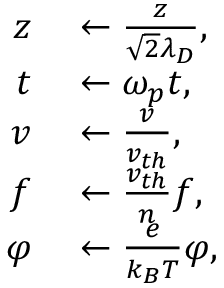Convert formula to latex. <formula><loc_0><loc_0><loc_500><loc_500>\begin{array} { r l } { z } & \leftarrow \frac { z } { \sqrt { 2 } \lambda _ { D } } , } \\ { t } & \leftarrow \omega _ { p } t , } \\ { v } & \leftarrow \frac { v } { v _ { t h } } , } \\ { f } & \leftarrow \frac { v _ { t h } } { n } f , } \\ { \varphi } & \leftarrow \frac { e } { k _ { B } T } \varphi , } \end{array}</formula> 